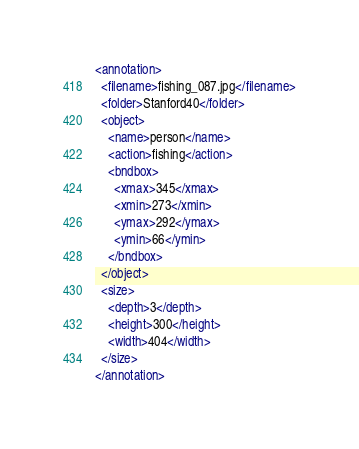Convert code to text. <code><loc_0><loc_0><loc_500><loc_500><_XML_><annotation>
  <filename>fishing_087.jpg</filename>
  <folder>Stanford40</folder>
  <object>
    <name>person</name>
    <action>fishing</action>
    <bndbox>
      <xmax>345</xmax>
      <xmin>273</xmin>
      <ymax>292</ymax>
      <ymin>66</ymin>
    </bndbox>
  </object>
  <size>
    <depth>3</depth>
    <height>300</height>
    <width>404</width>
  </size>
</annotation>
</code> 